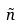<formula> <loc_0><loc_0><loc_500><loc_500>\tilde { n }</formula> 